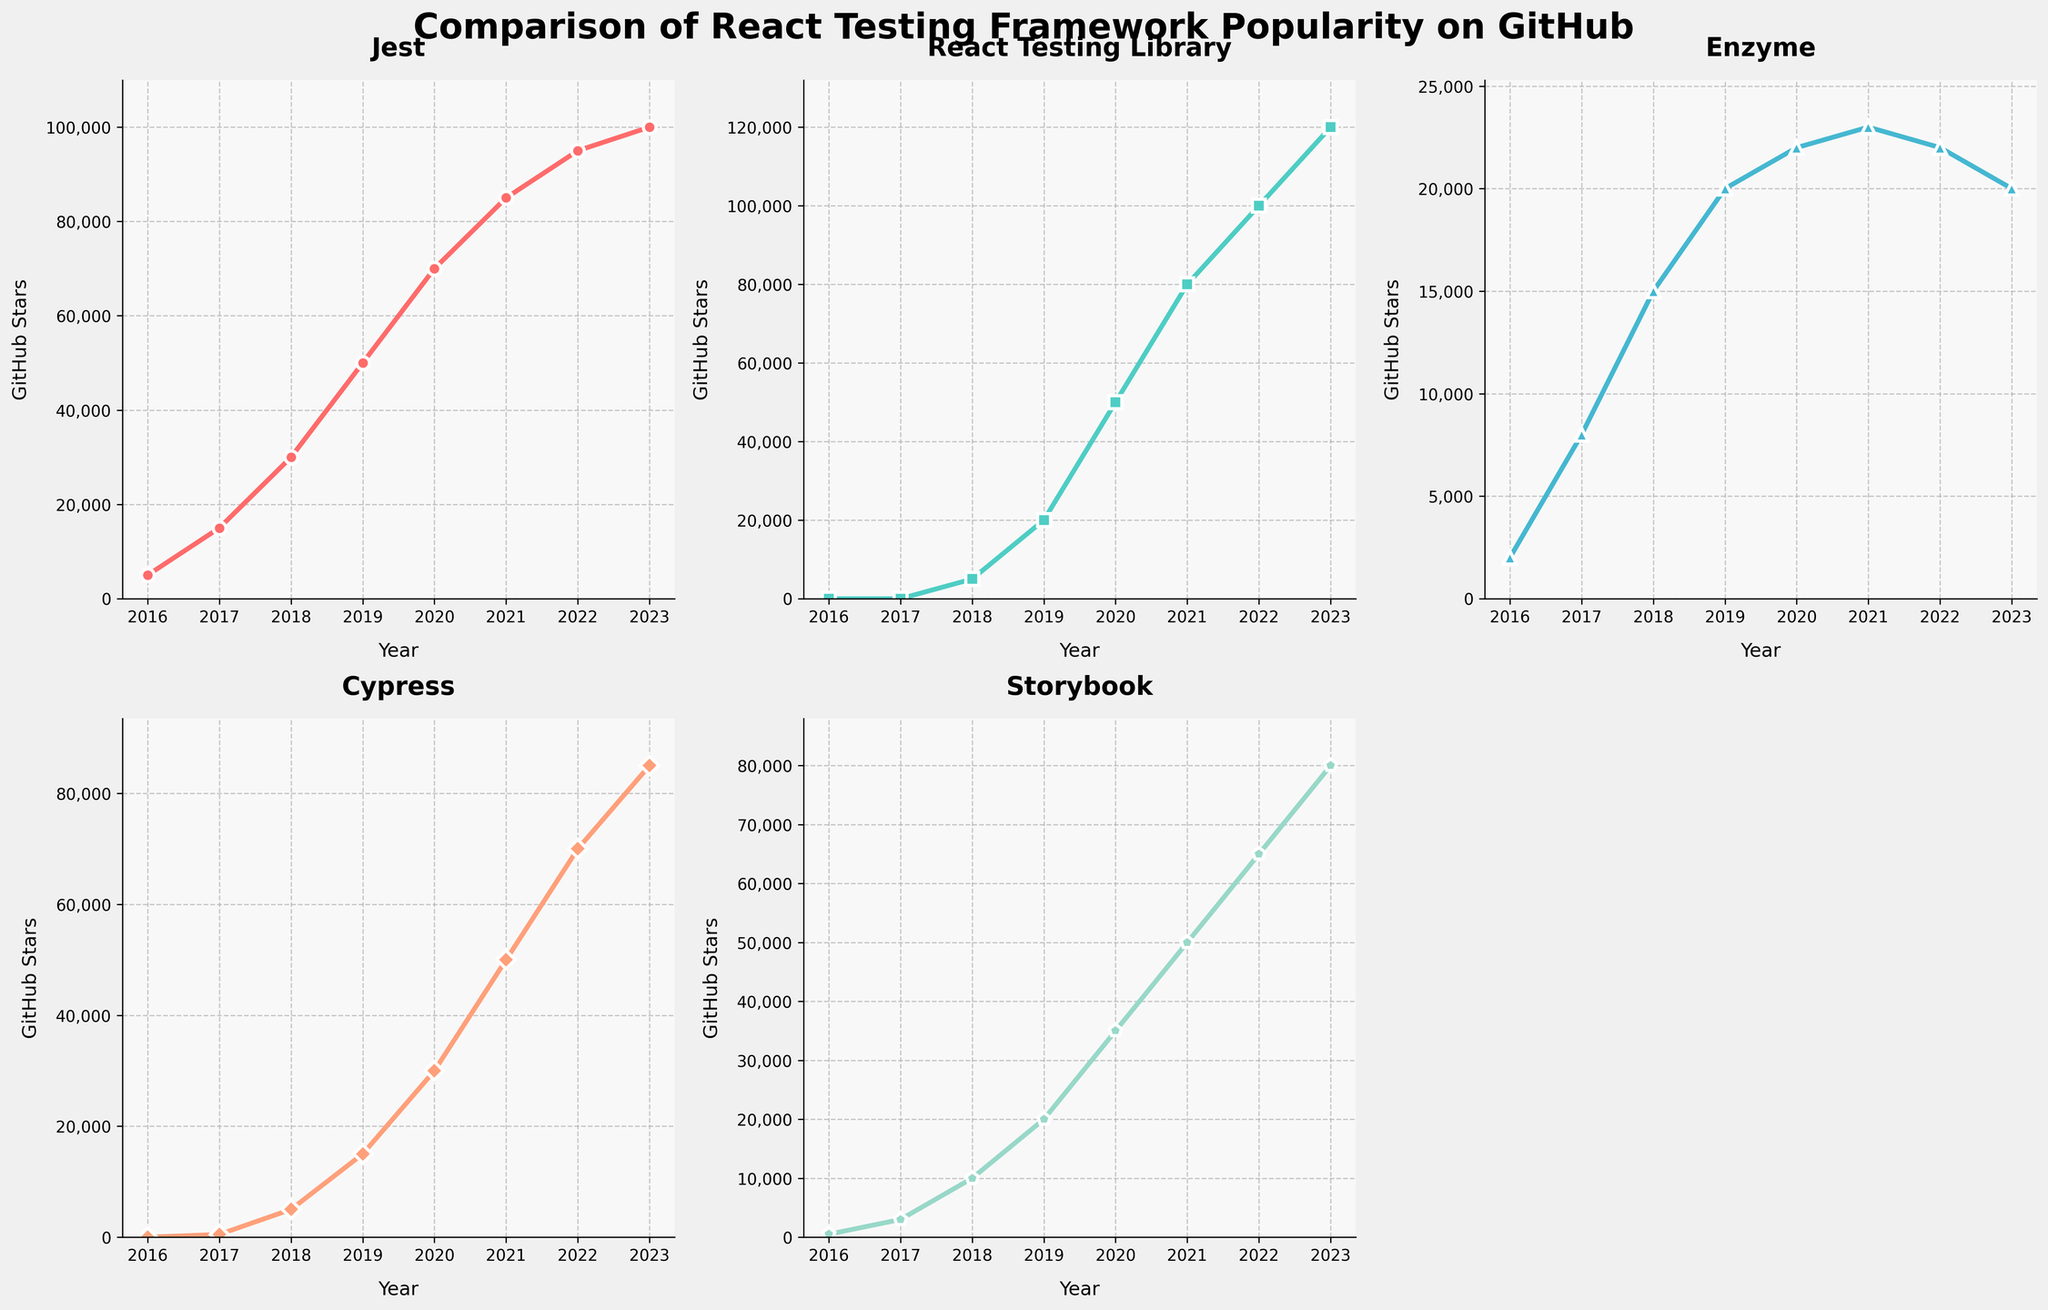What is the title of the figure? The title is displayed at the top of the figure in a large, bold font. It helps quickly understand the context of the data being presented.
Answer: Comparison of React Testing Framework Popularity on GitHub Which framework shows the highest growth in GitHub stars from 2016 to 2023? By inspecting the slopes of the lines in the subplots, React Testing Library shows the most significant increase in GitHub stars. It starts from 0 stars in 2016 and reaches 120,000 stars in 2023.
Answer: React Testing Library How many GitHub stars did Jest have in 2018? By looking at the data points in the Jest subplot corresponding to the year 2018, we see Jest had 30,000 stars.
Answer: 30,000 Which framework experienced a decline in GitHub stars from 2022 to 2023? By comparing the data points for 2022 and 2023, Enzyme shows a decrease in GitHub stars from 22,000 to 20,000 stars.
Answer: Enzyme Compare the number of GitHub stars between Cypress and Storybook in 2020. Which framework had more stars and by how much? In 2020, Cypress had 30,000 stars and Storybook had 35,000 stars. Therefore, Storybook had 5,000 more stars than Cypress.
Answer: Storybook by 5,000 stars What is the average number of stars for all frameworks in 2021? For each framework in 2021: Jest (85,000), React Testing Library (80,000), Enzyme (23,000), Cypress (50,000), and Storybook (50,000). Sum them up, 288,000, and divide by 5 frameworks: 288,000/5 = 57,600 stars.
Answer: 57,600 stars Which framework shows the most consistent growth in GitHub stars from 2016 to 2023? React Testing Library exhibits consistent year-on-year growth in GitHub stars without any periods of decline or stagnation across this period.
Answer: React Testing Library What year did Cypress surpass 50,000 GitHub stars? By examining the data points for Cypress, we see it surpassed 50,000 stars in the year 2021.
Answer: 2021 How many frameworks had more than 30,000 GitHub stars in 2019? By looking at the subplots for 2019, Jest, React Testing Library, and Storybook had more than 30,000 stars. Three frameworks reached this milestone.
Answer: 3 Which framework had the second-highest number of GitHub stars in 2023? For 2023, React Testing Library is the highest with 120,000 stars, and Storybook is the second-highest with 80,000 stars.
Answer: Storybook 